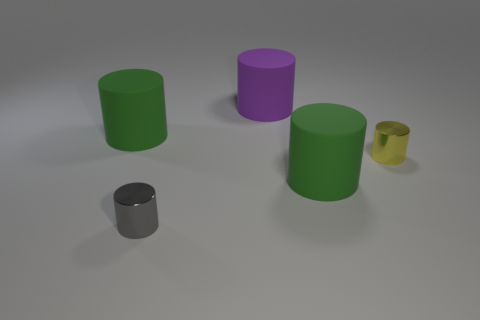How many rubber objects are big green cylinders or tiny yellow objects?
Provide a succinct answer. 2. How many metallic cylinders are on the right side of the large matte cylinder that is in front of the green cylinder that is left of the gray object?
Your answer should be compact. 1. What is the size of the gray object that is the same material as the yellow cylinder?
Make the answer very short. Small. Is the size of the green object to the left of the purple thing the same as the large purple thing?
Ensure brevity in your answer.  Yes. There is a cylinder that is behind the yellow thing and left of the big purple rubber cylinder; what color is it?
Offer a very short reply. Green. What number of things are large matte cylinders or large green rubber objects that are on the right side of the purple object?
Ensure brevity in your answer.  3. The large thing that is behind the large green cylinder that is on the left side of the small metallic thing in front of the small yellow object is made of what material?
Provide a short and direct response. Rubber. What number of yellow things are either large matte cylinders or small cylinders?
Provide a short and direct response. 1. What number of other things are the same shape as the yellow metal object?
Offer a very short reply. 4. Is the material of the gray object the same as the yellow thing?
Give a very brief answer. Yes. 